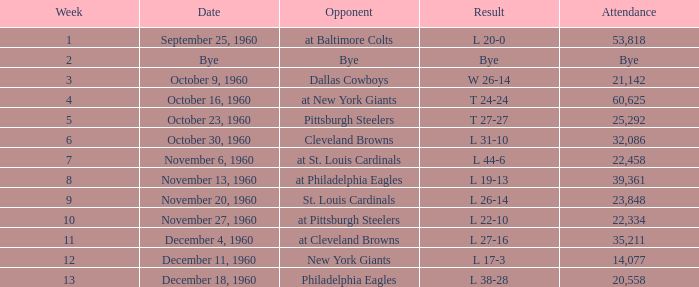Which Week had a Date of december 4, 1960? 11.0. 